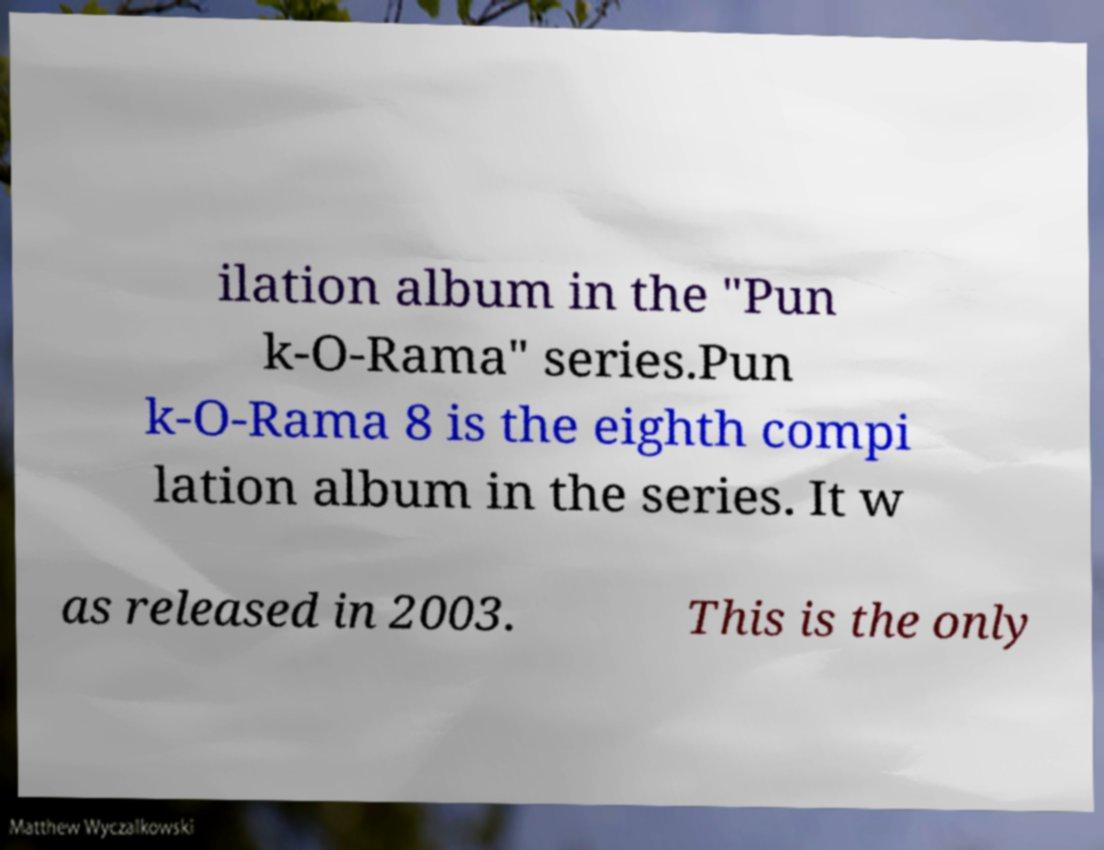Could you assist in decoding the text presented in this image and type it out clearly? ilation album in the "Pun k-O-Rama" series.Pun k-O-Rama 8 is the eighth compi lation album in the series. It w as released in 2003. This is the only 